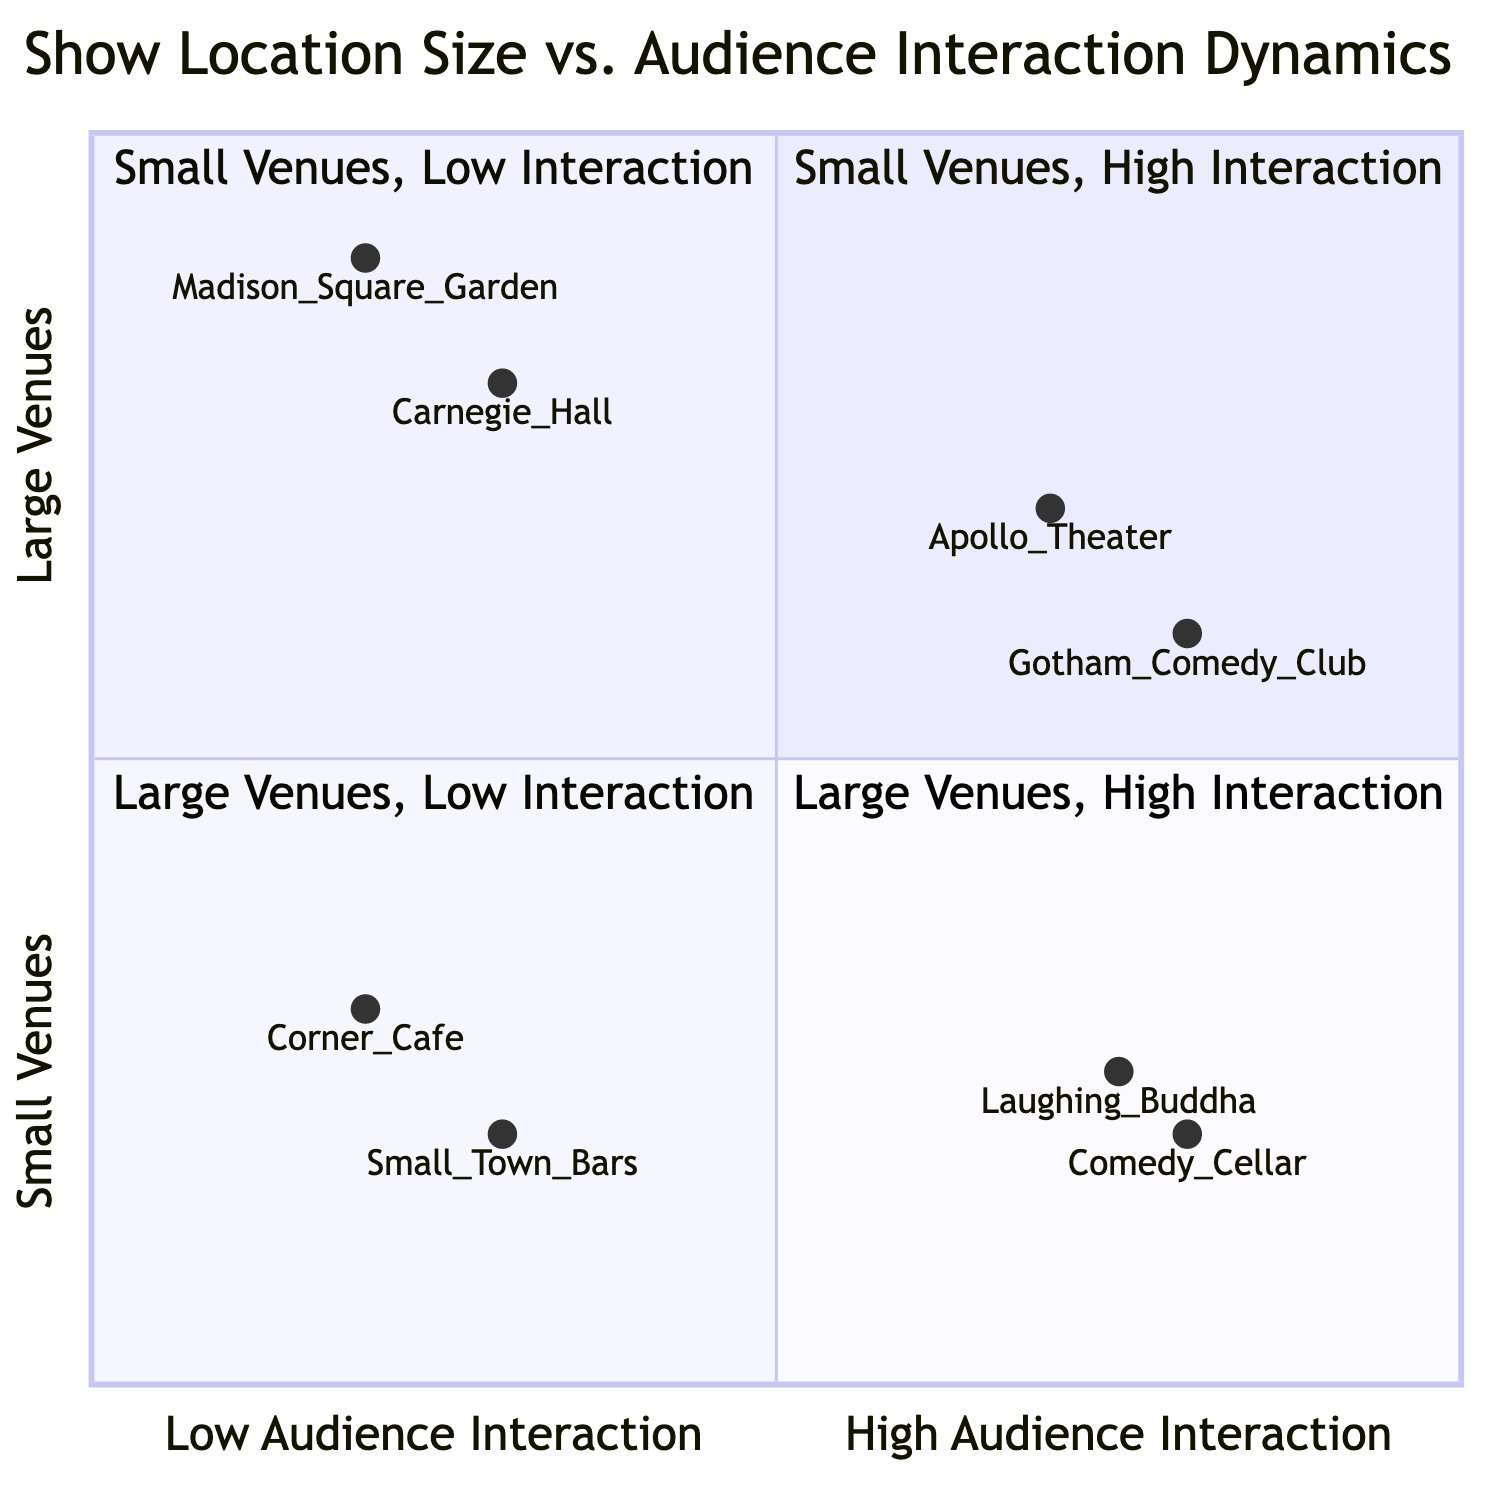What venues are represented in Q1? Q1 includes "The Comedy Cellar" and "Laughing Buddha Comedy Club" based on the data provided.
Answer: The Comedy Cellar, Laughing Buddha Comedy Club What challenges are associated with Q2? The challenges listed for Q2 include "Quiet Audience" and "Hard to Gauge Response", indicating difficulties in engaging with the audience in smaller venues with low interaction.
Answer: Quiet Audience, Hard to Gauge Response Which quadrant features venues with echoed laughter? The only quadrant listed that focuses on "Echoed Laughter, Amplified Reactions" is Q3, which includes venues like "Apollo Theater" and "Gotham Comedy Club".
Answer: Q3 How many example venues are mentioned in Q4? Q4 has two example venues mentioned, specifically "Carnegie Hall" and "Madison Square Garden (large events)", making it two in total.
Answer: 2 Which venue has the highest level of audience interaction? By examining the audience interaction values, "Apollo Theater" has the highest value of 0.7, making it the highest in interaction.
Answer: Apollo Theater What is a challenge for venues in Q3? The listed challenge for Q3 is "Keeping the Energy Consistent", which addresses difficulty in maintaining the same level of audience enthusiasm in larger settings.
Answer: Keeping the Energy Consistent What type of venues does Q1 focus on? Q1 focuses on "Small Venues with High Audience Interaction," highlighting the dynamic and engaged atmosphere typical of smaller venues.
Answer: Small Venues with High Audience Interaction In which quadrant is the "corner café open mic"? The "Corner Café Open Mic" is positioned in Q2, which corresponds to "Small Venues with Low Audience Interaction".
Answer: Q2 